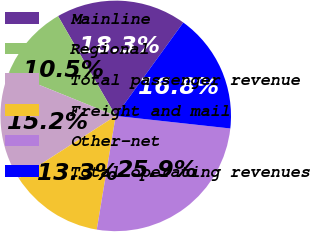Convert chart to OTSL. <chart><loc_0><loc_0><loc_500><loc_500><pie_chart><fcel>Mainline<fcel>Regional<fcel>Total passenger revenue<fcel>Freight and mail<fcel>Other-net<fcel>Total operating revenues<nl><fcel>18.31%<fcel>10.53%<fcel>15.24%<fcel>13.26%<fcel>25.89%<fcel>16.77%<nl></chart> 